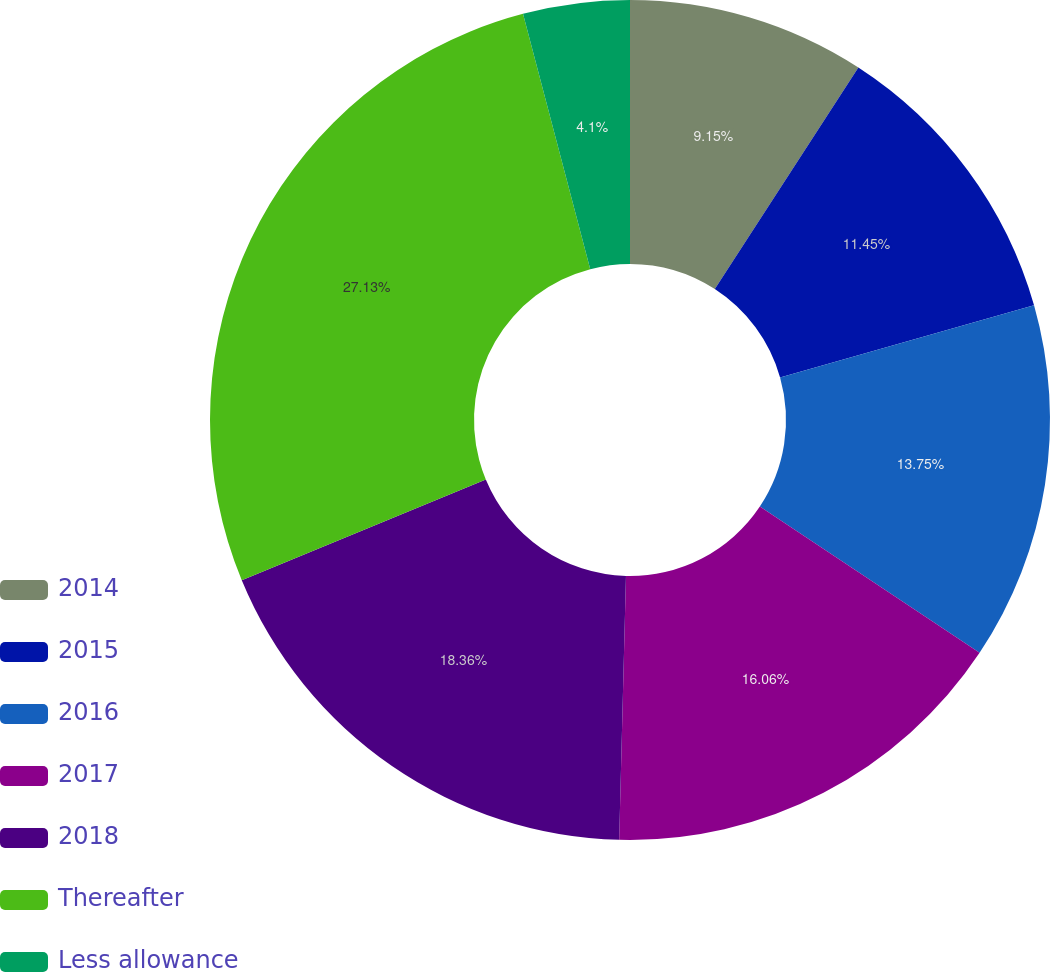Convert chart to OTSL. <chart><loc_0><loc_0><loc_500><loc_500><pie_chart><fcel>2014<fcel>2015<fcel>2016<fcel>2017<fcel>2018<fcel>Thereafter<fcel>Less allowance<nl><fcel>9.15%<fcel>11.45%<fcel>13.75%<fcel>16.06%<fcel>18.36%<fcel>27.13%<fcel>4.1%<nl></chart> 